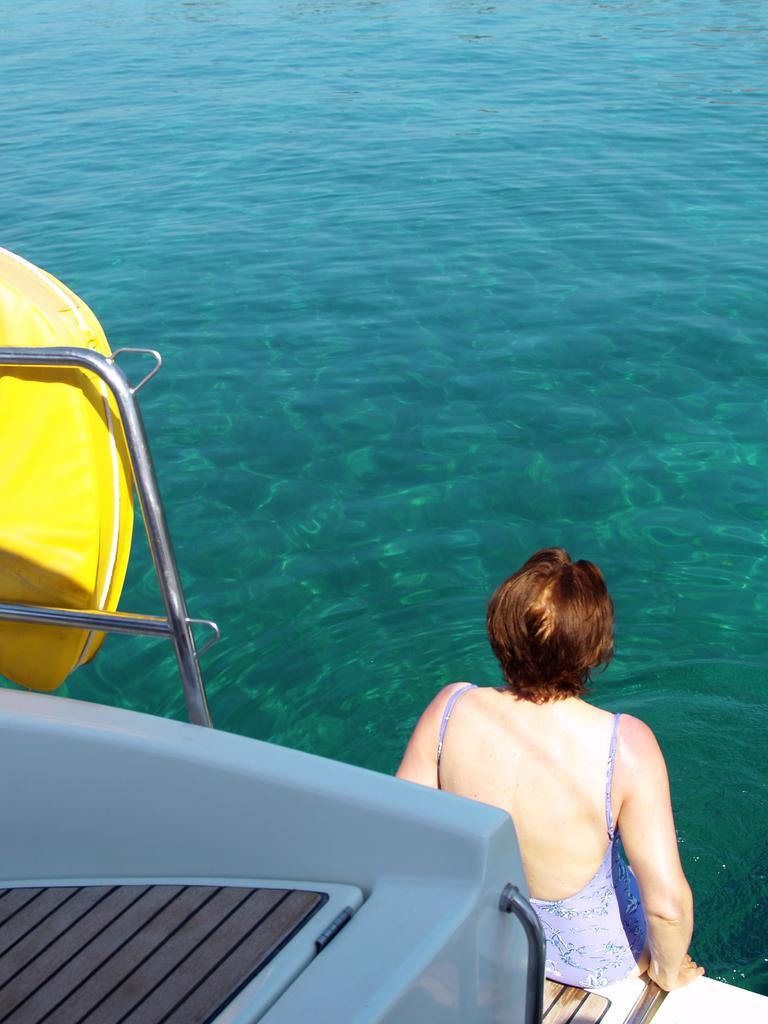Who or what can be seen in the image? There is a person in the image. What is the person doing in the image? The person is sitting on a boat. Where is the boat located in the image? The boat is on the water. What type of harmony is being played by the company in the image? There is no mention of harmony, company, or any musical instruments in the image. The image only shows a person sitting on a boat on the water. 